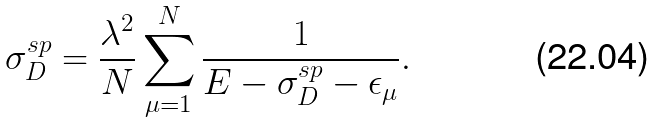<formula> <loc_0><loc_0><loc_500><loc_500>\sigma _ { D } ^ { s p } = \frac { \lambda ^ { 2 } } { N } \sum _ { \mu = 1 } ^ { N } \frac { 1 } { E - \sigma _ { D } ^ { s p } - \epsilon _ { \mu } } .</formula> 